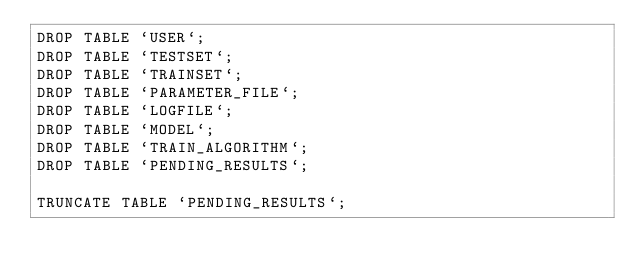<code> <loc_0><loc_0><loc_500><loc_500><_SQL_>DROP TABLE `USER`;
DROP TABLE `TESTSET`;
DROP TABLE `TRAINSET`;
DROP TABLE `PARAMETER_FILE`;
DROP TABLE `LOGFILE`;
DROP TABLE `MODEL`;
DROP TABLE `TRAIN_ALGORITHM`;
DROP TABLE `PENDING_RESULTS`;

TRUNCATE TABLE `PENDING_RESULTS`;</code> 